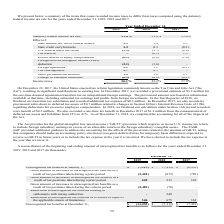Comparing values in Manhattan Associates's report, What is the statutory tax rate for 2017? According to the financial document, 35.0 (percentage). The relevant text states: "Statutory federal income tax rate 21.0 % 21.0 % 35.0 %..." Also, What is the amount for repatriation transition tax in 2017? According to the financial document, $3.3 million. The relevant text states: "cember 2017, we recorded a provisional estimate of $3.3 million for the one-time deemed repatriation transition tax on unrepatriated foreign earnings. The provision cember 2017, we recorded a provisio..." Also, What is the change caused by the global intangible low-taxed income provision? requires us in our U.S. income tax return, to include foreign subsidiary earnings in excess of an allowable return on the foreign subsidiary’s tangible assets. The document states: "ngible low-taxed income (“GILTI”) provision which requires us in our U.S. income tax return, to include foreign subsidiary earnings in excess of an al..." Also, can you calculate: What is the change in the income tax rates between 2019 and 2018? Based on the calculation: 26.1%-23.2%, the result is 2.9 (percentage). This is based on the information: "Income taxes 26.1 % 23.2 % 37.0 % Income taxes 26.1 % 23.2 % 37.0 %..." The key data points involved are: 23.2, 26.1. Also, can you calculate: What is the change in foreign operation tax between 2019 and 2018? Based on the calculation: 1.2-1.1, the result is 0.1 (percentage). This is based on the information: "Foreign operations 1.1 1.2 (0.1 ) Foreign operations 1.1 1.2 (0.1 )..." The key data points involved are: 1.1, 1.2. Additionally, Which year has the highest Statutory federal income tax rate? According to the financial document, 2017. The relevant text states: "2019 2018 2017..." 